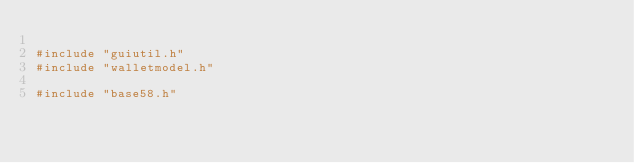<code> <loc_0><loc_0><loc_500><loc_500><_C++_>
#include "guiutil.h"
#include "walletmodel.h"

#include "base58.h"</code> 